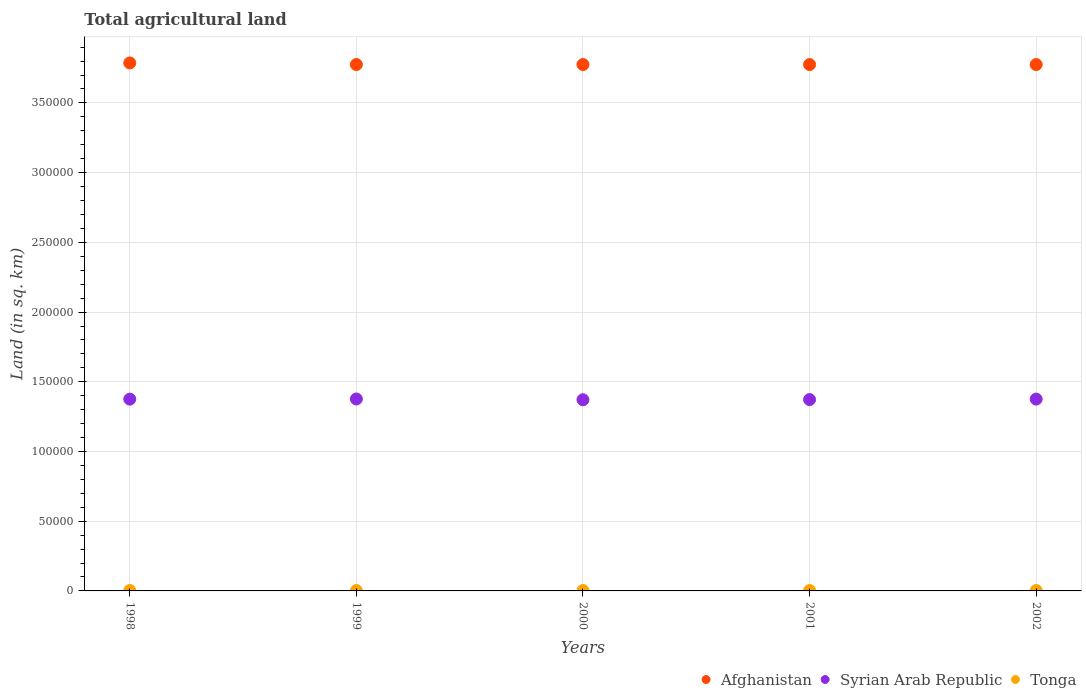What is the total agricultural land in Afghanistan in 1999?
Ensure brevity in your answer.  3.78e+05. Across all years, what is the maximum total agricultural land in Tonga?
Ensure brevity in your answer.  310. Across all years, what is the minimum total agricultural land in Tonga?
Offer a terse response. 300. In which year was the total agricultural land in Afghanistan minimum?
Offer a terse response. 1999. What is the total total agricultural land in Afghanistan in the graph?
Provide a short and direct response. 1.89e+06. What is the difference between the total agricultural land in Tonga in 1998 and that in 2002?
Ensure brevity in your answer.  10. What is the difference between the total agricultural land in Syrian Arab Republic in 1998 and the total agricultural land in Tonga in 2002?
Provide a succinct answer. 1.37e+05. What is the average total agricultural land in Afghanistan per year?
Keep it short and to the point. 3.78e+05. In the year 2001, what is the difference between the total agricultural land in Tonga and total agricultural land in Syrian Arab Republic?
Keep it short and to the point. -1.37e+05. What is the ratio of the total agricultural land in Tonga in 1999 to that in 2000?
Give a very brief answer. 1.03. Is the total agricultural land in Syrian Arab Republic in 2001 less than that in 2002?
Offer a terse response. Yes. What is the difference between the highest and the lowest total agricultural land in Afghanistan?
Offer a terse response. 1140. In how many years, is the total agricultural land in Tonga greater than the average total agricultural land in Tonga taken over all years?
Offer a very short reply. 2. Is the sum of the total agricultural land in Tonga in 1998 and 1999 greater than the maximum total agricultural land in Syrian Arab Republic across all years?
Offer a terse response. No. Is it the case that in every year, the sum of the total agricultural land in Syrian Arab Republic and total agricultural land in Tonga  is greater than the total agricultural land in Afghanistan?
Make the answer very short. No. Is the total agricultural land in Afghanistan strictly greater than the total agricultural land in Tonga over the years?
Offer a terse response. Yes. How many dotlines are there?
Provide a succinct answer. 3. Are the values on the major ticks of Y-axis written in scientific E-notation?
Give a very brief answer. No. Does the graph contain any zero values?
Give a very brief answer. No. Does the graph contain grids?
Your answer should be compact. Yes. How are the legend labels stacked?
Make the answer very short. Horizontal. What is the title of the graph?
Provide a succinct answer. Total agricultural land. Does "Sweden" appear as one of the legend labels in the graph?
Give a very brief answer. No. What is the label or title of the X-axis?
Ensure brevity in your answer.  Years. What is the label or title of the Y-axis?
Provide a short and direct response. Land (in sq. km). What is the Land (in sq. km) of Afghanistan in 1998?
Your answer should be compact. 3.79e+05. What is the Land (in sq. km) in Syrian Arab Republic in 1998?
Provide a succinct answer. 1.38e+05. What is the Land (in sq. km) in Tonga in 1998?
Keep it short and to the point. 310. What is the Land (in sq. km) of Afghanistan in 1999?
Provide a succinct answer. 3.78e+05. What is the Land (in sq. km) of Syrian Arab Republic in 1999?
Provide a short and direct response. 1.38e+05. What is the Land (in sq. km) of Tonga in 1999?
Give a very brief answer. 310. What is the Land (in sq. km) of Afghanistan in 2000?
Ensure brevity in your answer.  3.78e+05. What is the Land (in sq. km) in Syrian Arab Republic in 2000?
Your answer should be compact. 1.37e+05. What is the Land (in sq. km) in Tonga in 2000?
Make the answer very short. 300. What is the Land (in sq. km) in Afghanistan in 2001?
Provide a short and direct response. 3.78e+05. What is the Land (in sq. km) in Syrian Arab Republic in 2001?
Offer a terse response. 1.37e+05. What is the Land (in sq. km) in Tonga in 2001?
Your response must be concise. 300. What is the Land (in sq. km) in Afghanistan in 2002?
Your answer should be very brief. 3.78e+05. What is the Land (in sq. km) in Syrian Arab Republic in 2002?
Your answer should be compact. 1.38e+05. What is the Land (in sq. km) in Tonga in 2002?
Give a very brief answer. 300. Across all years, what is the maximum Land (in sq. km) of Afghanistan?
Your answer should be very brief. 3.79e+05. Across all years, what is the maximum Land (in sq. km) of Syrian Arab Republic?
Provide a short and direct response. 1.38e+05. Across all years, what is the maximum Land (in sq. km) of Tonga?
Make the answer very short. 310. Across all years, what is the minimum Land (in sq. km) in Afghanistan?
Provide a short and direct response. 3.78e+05. Across all years, what is the minimum Land (in sq. km) of Syrian Arab Republic?
Make the answer very short. 1.37e+05. Across all years, what is the minimum Land (in sq. km) in Tonga?
Provide a short and direct response. 300. What is the total Land (in sq. km) in Afghanistan in the graph?
Your response must be concise. 1.89e+06. What is the total Land (in sq. km) of Syrian Arab Republic in the graph?
Provide a succinct answer. 6.87e+05. What is the total Land (in sq. km) of Tonga in the graph?
Provide a short and direct response. 1520. What is the difference between the Land (in sq. km) of Afghanistan in 1998 and that in 1999?
Offer a very short reply. 1140. What is the difference between the Land (in sq. km) in Syrian Arab Republic in 1998 and that in 1999?
Ensure brevity in your answer.  -130. What is the difference between the Land (in sq. km) of Afghanistan in 1998 and that in 2000?
Your answer should be very brief. 1140. What is the difference between the Land (in sq. km) in Syrian Arab Republic in 1998 and that in 2000?
Provide a succinct answer. 430. What is the difference between the Land (in sq. km) in Afghanistan in 1998 and that in 2001?
Your response must be concise. 1140. What is the difference between the Land (in sq. km) in Syrian Arab Republic in 1998 and that in 2001?
Your answer should be very brief. 310. What is the difference between the Land (in sq. km) of Afghanistan in 1998 and that in 2002?
Provide a succinct answer. 1140. What is the difference between the Land (in sq. km) of Afghanistan in 1999 and that in 2000?
Keep it short and to the point. 0. What is the difference between the Land (in sq. km) in Syrian Arab Republic in 1999 and that in 2000?
Your answer should be very brief. 560. What is the difference between the Land (in sq. km) in Tonga in 1999 and that in 2000?
Your answer should be very brief. 10. What is the difference between the Land (in sq. km) of Syrian Arab Republic in 1999 and that in 2001?
Provide a short and direct response. 440. What is the difference between the Land (in sq. km) of Tonga in 1999 and that in 2002?
Provide a succinct answer. 10. What is the difference between the Land (in sq. km) of Afghanistan in 2000 and that in 2001?
Offer a very short reply. 0. What is the difference between the Land (in sq. km) in Syrian Arab Republic in 2000 and that in 2001?
Ensure brevity in your answer.  -120. What is the difference between the Land (in sq. km) of Afghanistan in 2000 and that in 2002?
Offer a very short reply. 0. What is the difference between the Land (in sq. km) in Syrian Arab Republic in 2000 and that in 2002?
Give a very brief answer. -480. What is the difference between the Land (in sq. km) of Afghanistan in 2001 and that in 2002?
Your answer should be very brief. 0. What is the difference between the Land (in sq. km) of Syrian Arab Republic in 2001 and that in 2002?
Give a very brief answer. -360. What is the difference between the Land (in sq. km) in Tonga in 2001 and that in 2002?
Offer a very short reply. 0. What is the difference between the Land (in sq. km) of Afghanistan in 1998 and the Land (in sq. km) of Syrian Arab Republic in 1999?
Ensure brevity in your answer.  2.41e+05. What is the difference between the Land (in sq. km) of Afghanistan in 1998 and the Land (in sq. km) of Tonga in 1999?
Your answer should be very brief. 3.78e+05. What is the difference between the Land (in sq. km) of Syrian Arab Republic in 1998 and the Land (in sq. km) of Tonga in 1999?
Make the answer very short. 1.37e+05. What is the difference between the Land (in sq. km) in Afghanistan in 1998 and the Land (in sq. km) in Syrian Arab Republic in 2000?
Give a very brief answer. 2.42e+05. What is the difference between the Land (in sq. km) in Afghanistan in 1998 and the Land (in sq. km) in Tonga in 2000?
Provide a succinct answer. 3.78e+05. What is the difference between the Land (in sq. km) of Syrian Arab Republic in 1998 and the Land (in sq. km) of Tonga in 2000?
Your response must be concise. 1.37e+05. What is the difference between the Land (in sq. km) of Afghanistan in 1998 and the Land (in sq. km) of Syrian Arab Republic in 2001?
Ensure brevity in your answer.  2.41e+05. What is the difference between the Land (in sq. km) of Afghanistan in 1998 and the Land (in sq. km) of Tonga in 2001?
Provide a succinct answer. 3.78e+05. What is the difference between the Land (in sq. km) in Syrian Arab Republic in 1998 and the Land (in sq. km) in Tonga in 2001?
Your answer should be compact. 1.37e+05. What is the difference between the Land (in sq. km) in Afghanistan in 1998 and the Land (in sq. km) in Syrian Arab Republic in 2002?
Offer a very short reply. 2.41e+05. What is the difference between the Land (in sq. km) of Afghanistan in 1998 and the Land (in sq. km) of Tonga in 2002?
Your response must be concise. 3.78e+05. What is the difference between the Land (in sq. km) of Syrian Arab Republic in 1998 and the Land (in sq. km) of Tonga in 2002?
Ensure brevity in your answer.  1.37e+05. What is the difference between the Land (in sq. km) of Afghanistan in 1999 and the Land (in sq. km) of Syrian Arab Republic in 2000?
Your answer should be very brief. 2.40e+05. What is the difference between the Land (in sq. km) in Afghanistan in 1999 and the Land (in sq. km) in Tonga in 2000?
Offer a very short reply. 3.77e+05. What is the difference between the Land (in sq. km) in Syrian Arab Republic in 1999 and the Land (in sq. km) in Tonga in 2000?
Your answer should be very brief. 1.37e+05. What is the difference between the Land (in sq. km) in Afghanistan in 1999 and the Land (in sq. km) in Syrian Arab Republic in 2001?
Give a very brief answer. 2.40e+05. What is the difference between the Land (in sq. km) in Afghanistan in 1999 and the Land (in sq. km) in Tonga in 2001?
Offer a very short reply. 3.77e+05. What is the difference between the Land (in sq. km) in Syrian Arab Republic in 1999 and the Land (in sq. km) in Tonga in 2001?
Offer a terse response. 1.37e+05. What is the difference between the Land (in sq. km) of Afghanistan in 1999 and the Land (in sq. km) of Syrian Arab Republic in 2002?
Give a very brief answer. 2.40e+05. What is the difference between the Land (in sq. km) in Afghanistan in 1999 and the Land (in sq. km) in Tonga in 2002?
Offer a terse response. 3.77e+05. What is the difference between the Land (in sq. km) in Syrian Arab Republic in 1999 and the Land (in sq. km) in Tonga in 2002?
Ensure brevity in your answer.  1.37e+05. What is the difference between the Land (in sq. km) of Afghanistan in 2000 and the Land (in sq. km) of Syrian Arab Republic in 2001?
Give a very brief answer. 2.40e+05. What is the difference between the Land (in sq. km) in Afghanistan in 2000 and the Land (in sq. km) in Tonga in 2001?
Provide a succinct answer. 3.77e+05. What is the difference between the Land (in sq. km) of Syrian Arab Republic in 2000 and the Land (in sq. km) of Tonga in 2001?
Your response must be concise. 1.37e+05. What is the difference between the Land (in sq. km) of Afghanistan in 2000 and the Land (in sq. km) of Syrian Arab Republic in 2002?
Keep it short and to the point. 2.40e+05. What is the difference between the Land (in sq. km) in Afghanistan in 2000 and the Land (in sq. km) in Tonga in 2002?
Make the answer very short. 3.77e+05. What is the difference between the Land (in sq. km) of Syrian Arab Republic in 2000 and the Land (in sq. km) of Tonga in 2002?
Offer a very short reply. 1.37e+05. What is the difference between the Land (in sq. km) in Afghanistan in 2001 and the Land (in sq. km) in Syrian Arab Republic in 2002?
Your response must be concise. 2.40e+05. What is the difference between the Land (in sq. km) of Afghanistan in 2001 and the Land (in sq. km) of Tonga in 2002?
Ensure brevity in your answer.  3.77e+05. What is the difference between the Land (in sq. km) of Syrian Arab Republic in 2001 and the Land (in sq. km) of Tonga in 2002?
Keep it short and to the point. 1.37e+05. What is the average Land (in sq. km) in Afghanistan per year?
Give a very brief answer. 3.78e+05. What is the average Land (in sq. km) in Syrian Arab Republic per year?
Ensure brevity in your answer.  1.37e+05. What is the average Land (in sq. km) in Tonga per year?
Give a very brief answer. 304. In the year 1998, what is the difference between the Land (in sq. km) of Afghanistan and Land (in sq. km) of Syrian Arab Republic?
Ensure brevity in your answer.  2.41e+05. In the year 1998, what is the difference between the Land (in sq. km) of Afghanistan and Land (in sq. km) of Tonga?
Your response must be concise. 3.78e+05. In the year 1998, what is the difference between the Land (in sq. km) of Syrian Arab Republic and Land (in sq. km) of Tonga?
Ensure brevity in your answer.  1.37e+05. In the year 1999, what is the difference between the Land (in sq. km) in Afghanistan and Land (in sq. km) in Syrian Arab Republic?
Give a very brief answer. 2.40e+05. In the year 1999, what is the difference between the Land (in sq. km) in Afghanistan and Land (in sq. km) in Tonga?
Your response must be concise. 3.77e+05. In the year 1999, what is the difference between the Land (in sq. km) in Syrian Arab Republic and Land (in sq. km) in Tonga?
Provide a succinct answer. 1.37e+05. In the year 2000, what is the difference between the Land (in sq. km) in Afghanistan and Land (in sq. km) in Syrian Arab Republic?
Your answer should be very brief. 2.40e+05. In the year 2000, what is the difference between the Land (in sq. km) in Afghanistan and Land (in sq. km) in Tonga?
Your response must be concise. 3.77e+05. In the year 2000, what is the difference between the Land (in sq. km) of Syrian Arab Republic and Land (in sq. km) of Tonga?
Your response must be concise. 1.37e+05. In the year 2001, what is the difference between the Land (in sq. km) of Afghanistan and Land (in sq. km) of Syrian Arab Republic?
Keep it short and to the point. 2.40e+05. In the year 2001, what is the difference between the Land (in sq. km) of Afghanistan and Land (in sq. km) of Tonga?
Offer a terse response. 3.77e+05. In the year 2001, what is the difference between the Land (in sq. km) of Syrian Arab Republic and Land (in sq. km) of Tonga?
Provide a short and direct response. 1.37e+05. In the year 2002, what is the difference between the Land (in sq. km) in Afghanistan and Land (in sq. km) in Syrian Arab Republic?
Provide a short and direct response. 2.40e+05. In the year 2002, what is the difference between the Land (in sq. km) in Afghanistan and Land (in sq. km) in Tonga?
Offer a terse response. 3.77e+05. In the year 2002, what is the difference between the Land (in sq. km) of Syrian Arab Republic and Land (in sq. km) of Tonga?
Keep it short and to the point. 1.37e+05. What is the ratio of the Land (in sq. km) of Syrian Arab Republic in 1998 to that in 1999?
Offer a terse response. 1. What is the ratio of the Land (in sq. km) of Tonga in 1998 to that in 1999?
Provide a succinct answer. 1. What is the ratio of the Land (in sq. km) of Afghanistan in 1998 to that in 2000?
Your answer should be compact. 1. What is the ratio of the Land (in sq. km) of Afghanistan in 1998 to that in 2001?
Provide a short and direct response. 1. What is the ratio of the Land (in sq. km) in Syrian Arab Republic in 1998 to that in 2001?
Offer a very short reply. 1. What is the ratio of the Land (in sq. km) in Afghanistan in 1998 to that in 2002?
Your answer should be very brief. 1. What is the ratio of the Land (in sq. km) in Syrian Arab Republic in 1999 to that in 2000?
Keep it short and to the point. 1. What is the ratio of the Land (in sq. km) in Afghanistan in 1999 to that in 2001?
Ensure brevity in your answer.  1. What is the ratio of the Land (in sq. km) in Syrian Arab Republic in 1999 to that in 2001?
Provide a short and direct response. 1. What is the ratio of the Land (in sq. km) of Tonga in 1999 to that in 2001?
Ensure brevity in your answer.  1.03. What is the ratio of the Land (in sq. km) in Afghanistan in 1999 to that in 2002?
Your response must be concise. 1. What is the ratio of the Land (in sq. km) of Tonga in 2000 to that in 2001?
Provide a short and direct response. 1. What is the ratio of the Land (in sq. km) of Afghanistan in 2000 to that in 2002?
Give a very brief answer. 1. What is the ratio of the Land (in sq. km) in Syrian Arab Republic in 2000 to that in 2002?
Offer a terse response. 1. What is the ratio of the Land (in sq. km) of Tonga in 2000 to that in 2002?
Offer a terse response. 1. What is the ratio of the Land (in sq. km) of Afghanistan in 2001 to that in 2002?
Your answer should be compact. 1. What is the difference between the highest and the second highest Land (in sq. km) of Afghanistan?
Provide a short and direct response. 1140. What is the difference between the highest and the second highest Land (in sq. km) of Tonga?
Your response must be concise. 0. What is the difference between the highest and the lowest Land (in sq. km) in Afghanistan?
Give a very brief answer. 1140. What is the difference between the highest and the lowest Land (in sq. km) of Syrian Arab Republic?
Your response must be concise. 560. What is the difference between the highest and the lowest Land (in sq. km) in Tonga?
Make the answer very short. 10. 